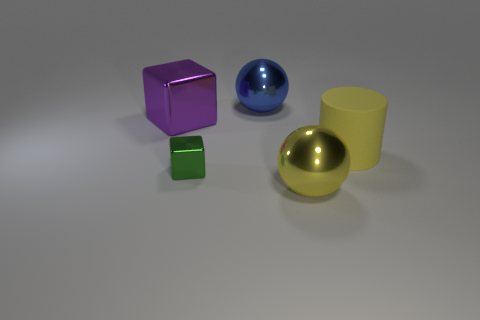Add 4 large blue metallic things. How many objects exist? 9 Subtract all cylinders. How many objects are left? 4 Subtract 1 yellow cylinders. How many objects are left? 4 Subtract all large metal balls. Subtract all red things. How many objects are left? 3 Add 2 blocks. How many blocks are left? 4 Add 1 big brown rubber cylinders. How many big brown rubber cylinders exist? 1 